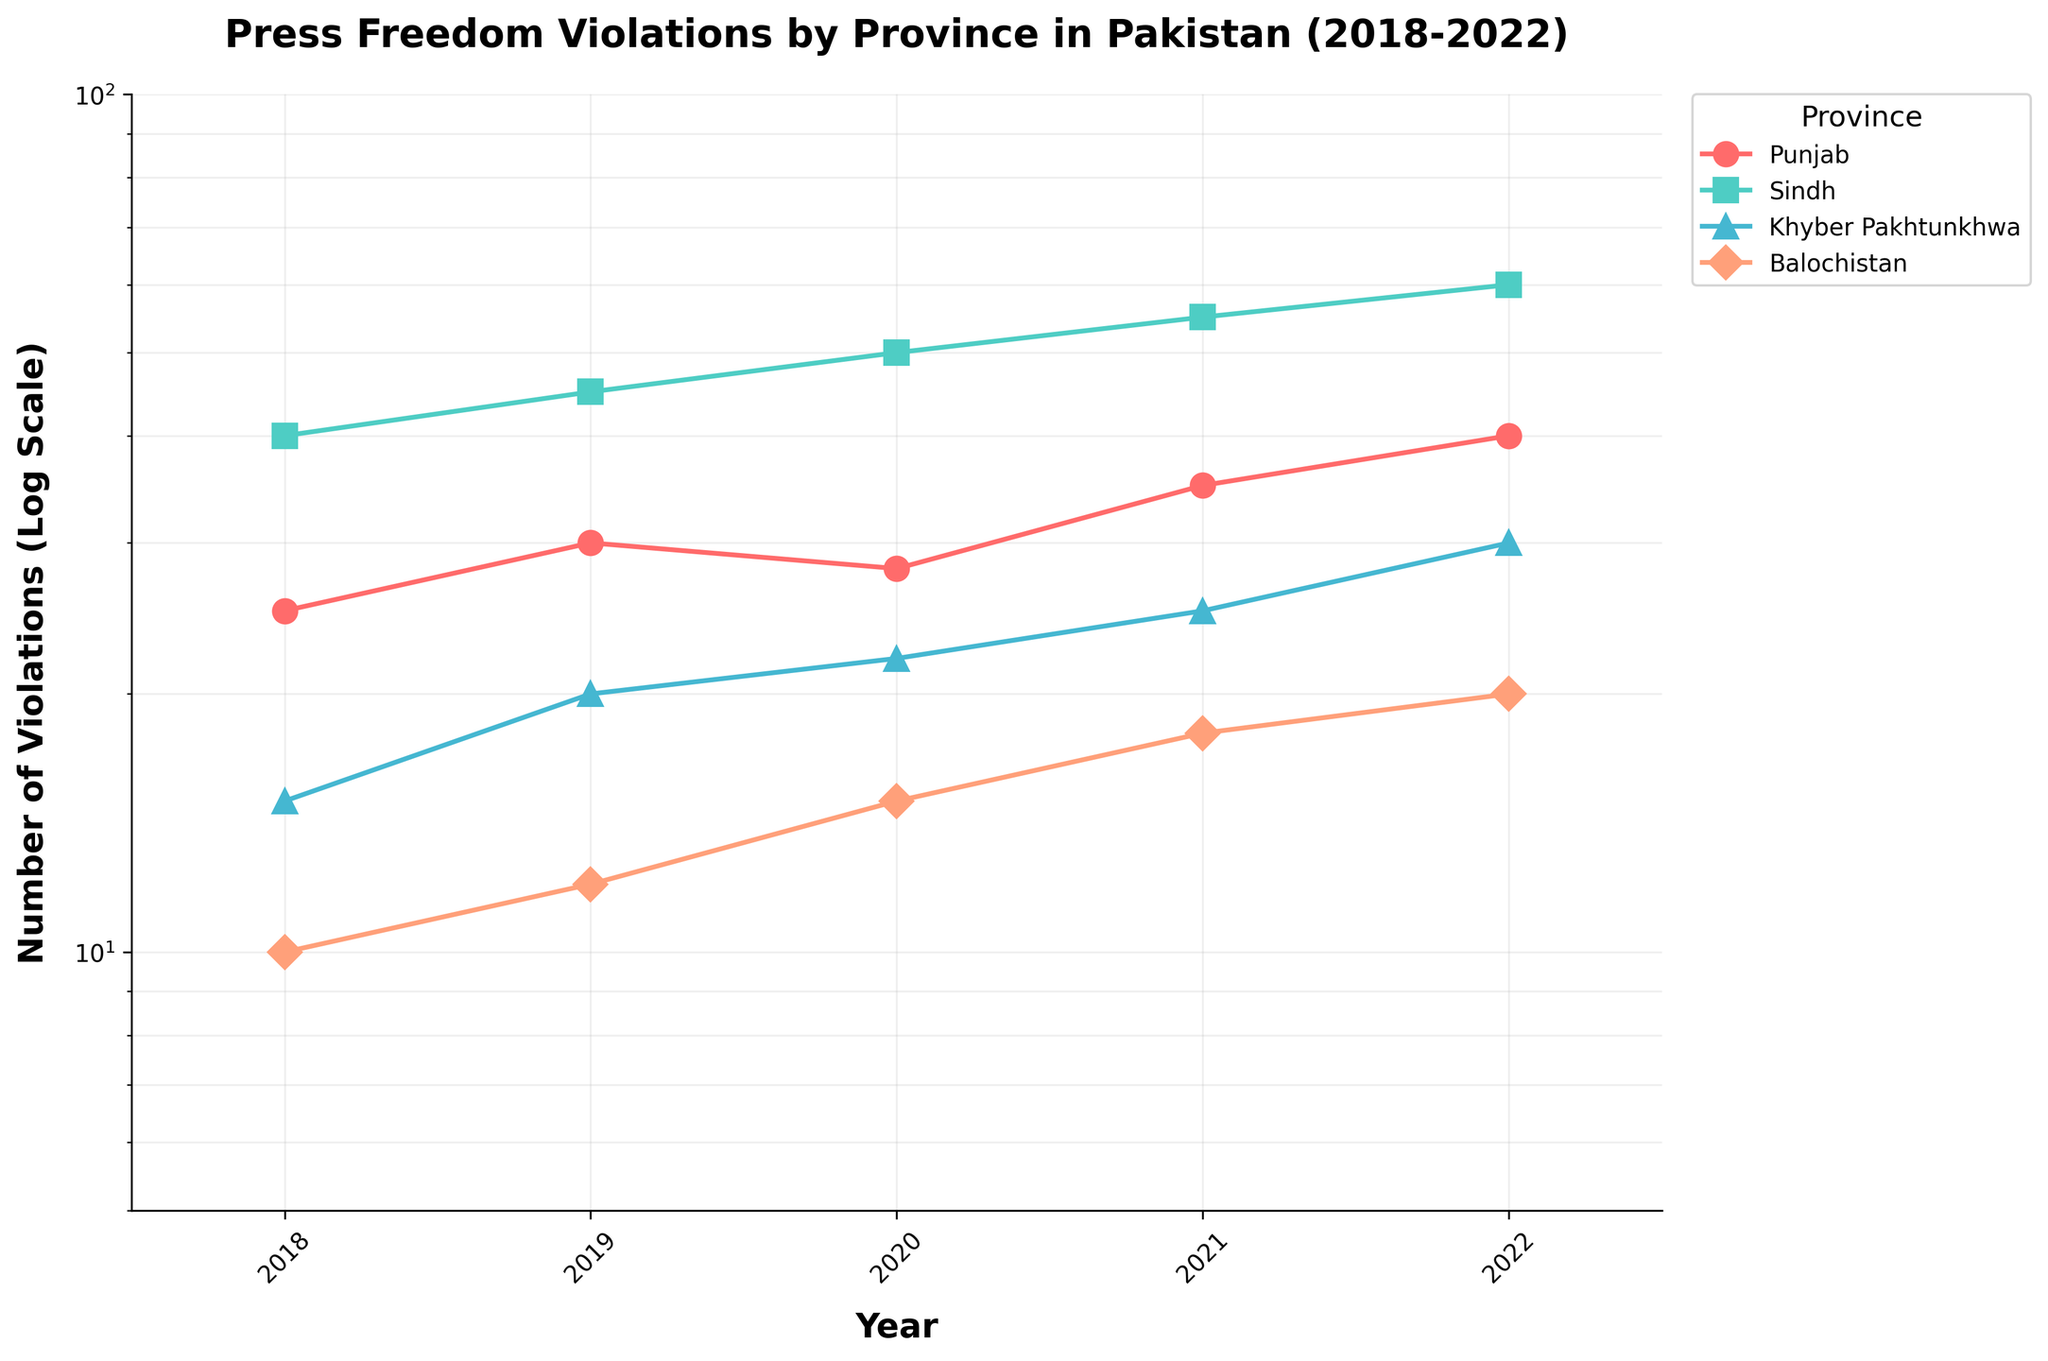Which province had the highest number of press freedom violations in 2022? From the chart, we can see that Sindh had the highest number of press freedom violations in 2022, as indicated by the highest data point on the vertical axis for that year.
Answer: Sindh What is the trend in the number of press freedom violations in Punjab from 2018 to 2022? The graph shows an overall increasing trend in the number of press freedom violations in Punjab from 2018 (25 violations) to 2022 (40 violations). This can be seen by the upward slope of the line representing Punjab over the years.
Answer: Increasing Which province saw the smallest change in the number of press freedom violations from 2018 to 2022? Balochistan had the smallest change, increasing from 10 in 2018 to 20 in 2022, which is an increase of 10 violations. The other provinces showed larger numerical changes over the same period.
Answer: Balochistan In which year did Khyber Pakhtunkhwa have the lowest number of press freedom violations? The graph shows that Khyber Pakhtunkhwa had the lowest number of violations in 2018, with 15 violations, as indicated by the lowest point on its line for that year.
Answer: 2018 How does the number of press freedom violations in Punjab in 2019 compare to those in Sindh the same year? From the chart, Punjab had 30 violations in 2019, while Sindh had 45 violations that same year. Sindh had a higher count.
Answer: Sindh had more violations What is the average number of press freedom violations in Balochistan from 2018 to 2022? The data points for Balochistan are: 10 (2018), 12 (2019), 15 (2020), 18 (2021), and 20 (2022). Adding these gives 75, and dividing by the 5 years gives an average of 15.
Answer: 15 On the logarithmic scale used in the chart, which years show the highest and lowest values for Sindh? The highest value for Sindh is in 2022 (60 violations), and the lowest is in 2018 (40 violations), as represented by the highest and lowest points on the line for Sindh.
Answer: 2022 and 2018 By what factor did the number of press freedom violations increase in Khyber Pakhtunkhwa from 2018 to 2022 on the log scale? Khyber Pakhtunkhwa had 15 violations in 2018 and 30 in 2022. On a logarithmic scale, the factor is 30/15 = 2, meaning the number doubled.
Answer: 2 Which province had a consistent year-over-year increase in press freedom violations from 2018 to 2022? Sindh shows a consistent increase each year from 2018 to 2022, indicated by the steadily rising line.
Answer: Sindh 